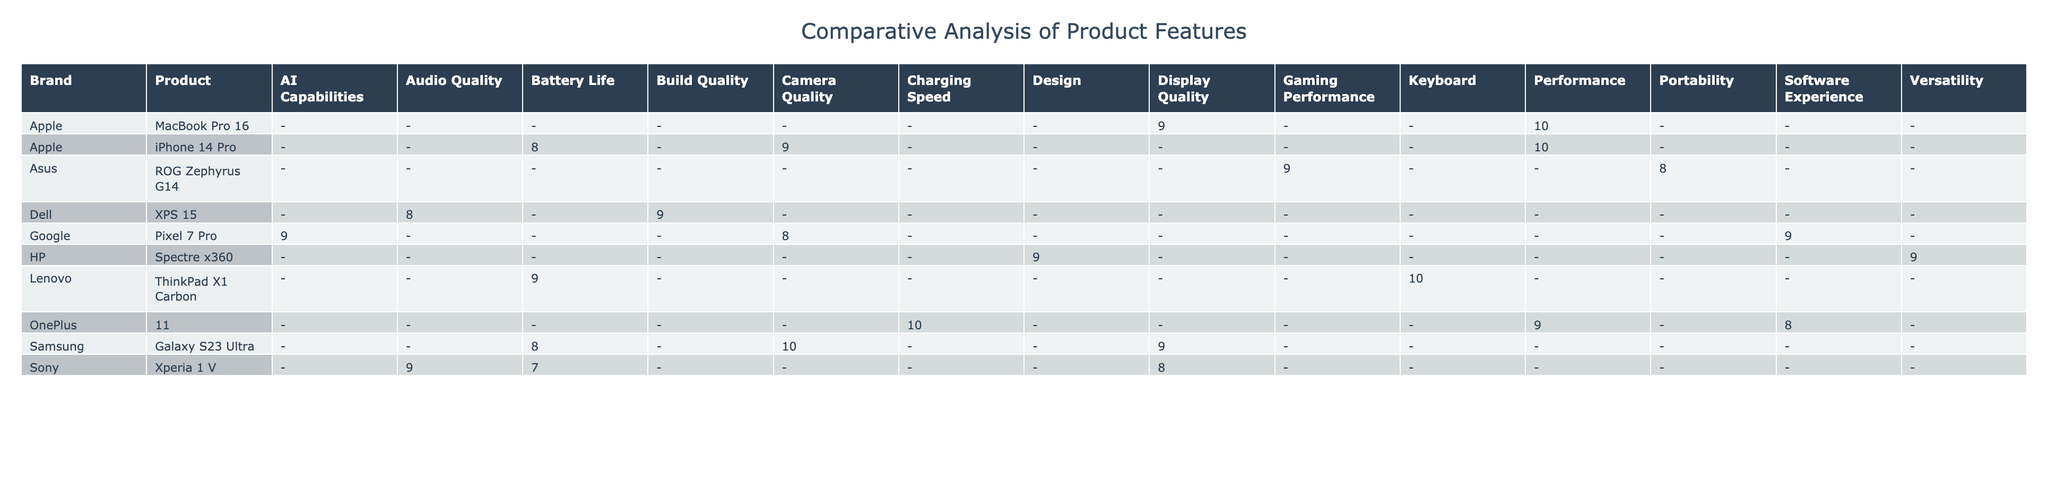What is the highest rating for Camera Quality? The table shows that the Galaxy S23 Ultra has a Camera Quality rating of 10, which is the highest value listed for this feature among all products.
Answer: 10 Which brand's product has the lowest Battery Life rating? Looking at the Battery Life ratings, the Sony Xperia 1 V has the lowest rating of 7 compared to other products listed.
Answer: Sony Xperia 1 V What is the average rating for products from Apple? To find the average rating for Apple products, we sum the ratings: (9 + 8 + 10 + 10 + 9) = 46. There are 5 Apple products, so the average rating is 46/5 = 9.2.
Answer: 9.2 Does the OnePlus 11 have the highest Charging Speed rating? The OnePlus 11 has a Charging Speed rating of 10, and there are no other listed products with this feature to compare it against. Thus, by default, the OnePlus 11 has the highest Charging Speed rating.
Answer: Yes Which product from Samsung has the best rating for Display Quality? The Galaxy S23 Ultra and the Xperia 1 V both have Display Quality ratings. However, the Galaxy S23 Ultra has a rating of 9, while the Xperia 1 V has a rating of 8. Therefore, the Galaxy S23 Ultra has the best rating for Display Quality among Samsung products.
Answer: Galaxy S23 Ultra If we compare the performance ratings of products from Dell and Lenovo, which one has a better rating? From the table, Dell's XPS 15 has a Performance rating of 9, while Lenovo's ThinkPad X1 Carbon has a rating of 9 as well. Both products have the same performance rating, making it impossible to distinguish a better performer based solely on these ratings.
Answer: They are equal What is the total price of the three Apple products listed? The prices for the Apple products are: iPhone 14 Pro at 999, iPhone 14 Pro (again) at 999, and MacBook Pro 16 at 2499. Adding these together: 999 + 999 + 2499 = 4497.
Answer: 4497 Which product has the highest Transparency Score? The highest Transparency Score is 9, which is associated with the Pixel 7 Pro and Lenovo ThinkPad X1 Carbon. Therefore, both products share this highest score.
Answer: Pixel 7 Pro and Lenovo ThinkPad X1 Carbon Which products have an Audio Quality rating lower than 9? The products with an Audio Quality rating lower than 9 are the Dell XPS 15 and Sony Xperia 1 V, which both have a rating of 8.
Answer: Dell XPS 15 and Sony Xperia 1 V 